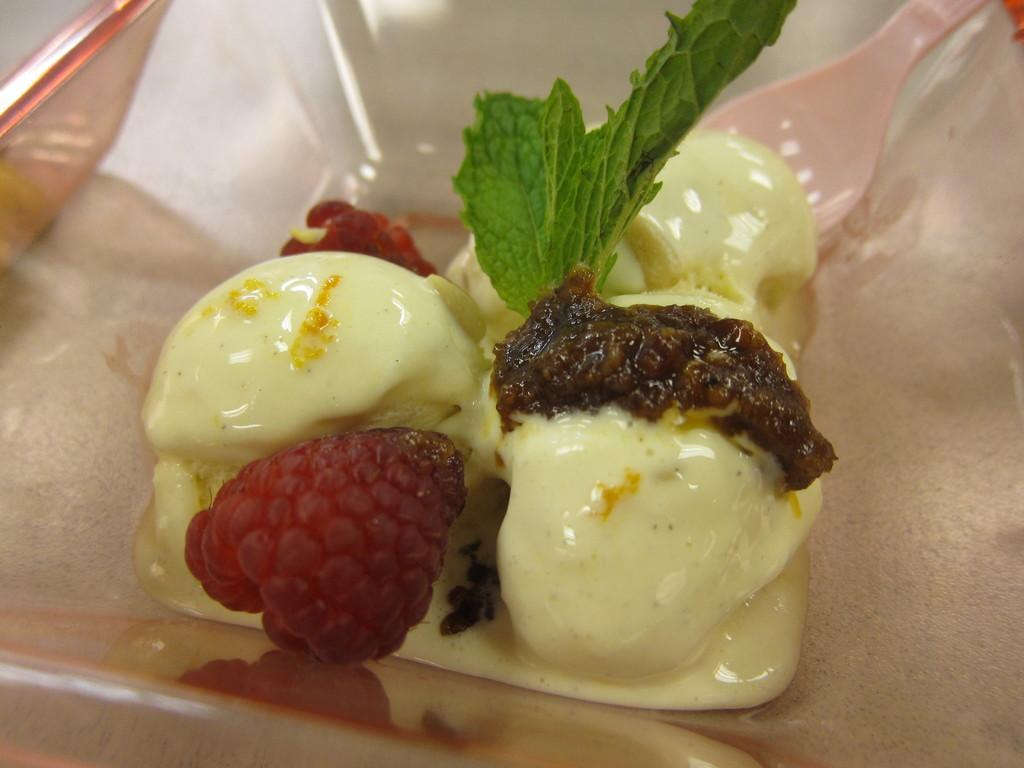What type of dessert is featured in the image? There is ice cream in the image. How is the ice cream contained in the image? The ice cream is in a glass bowl. What colors can be seen in the ice cream? The ice cream has cream, red, and brown colors. What utensil is present in the bowl? There is a spoon in the bowl. What type of skirt is visible in the image? There is no skirt present in the image; it features ice cream in a glass bowl. 